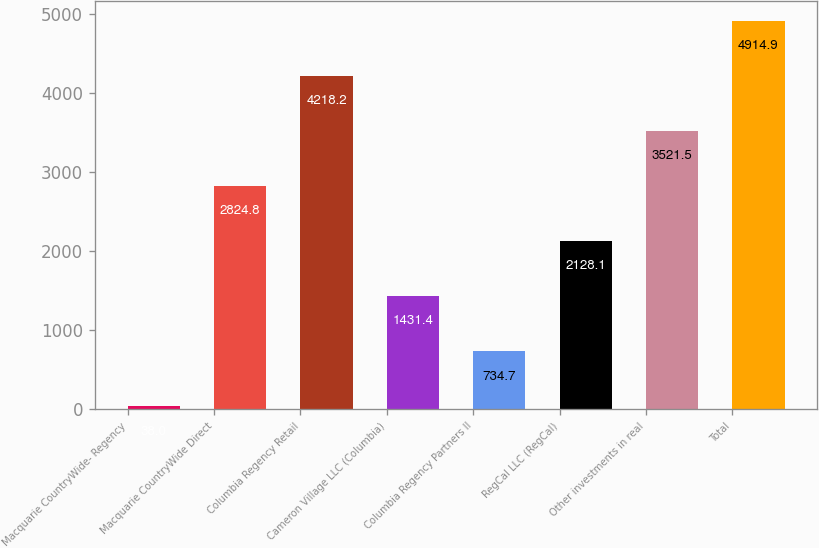Convert chart. <chart><loc_0><loc_0><loc_500><loc_500><bar_chart><fcel>Macquarie CountryWide- Regency<fcel>Macquarie CountryWide Direct<fcel>Columbia Regency Retail<fcel>Cameron Village LLC (Columbia)<fcel>Columbia Regency Partners II<fcel>RegCal LLC (RegCal)<fcel>Other investments in real<fcel>Total<nl><fcel>38<fcel>2824.8<fcel>4218.2<fcel>1431.4<fcel>734.7<fcel>2128.1<fcel>3521.5<fcel>4914.9<nl></chart> 